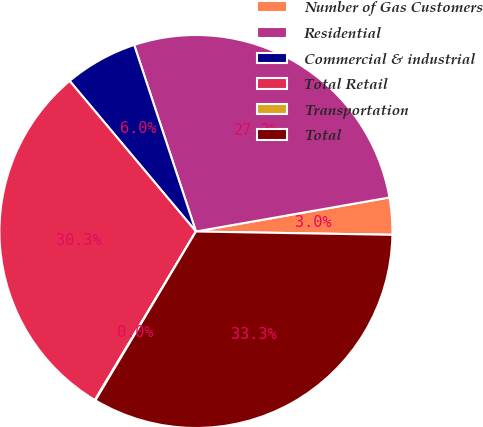<chart> <loc_0><loc_0><loc_500><loc_500><pie_chart><fcel>Number of Gas Customers<fcel>Residential<fcel>Commercial & industrial<fcel>Total Retail<fcel>Transportation<fcel>Total<nl><fcel>3.04%<fcel>27.32%<fcel>6.02%<fcel>30.3%<fcel>0.05%<fcel>33.28%<nl></chart> 